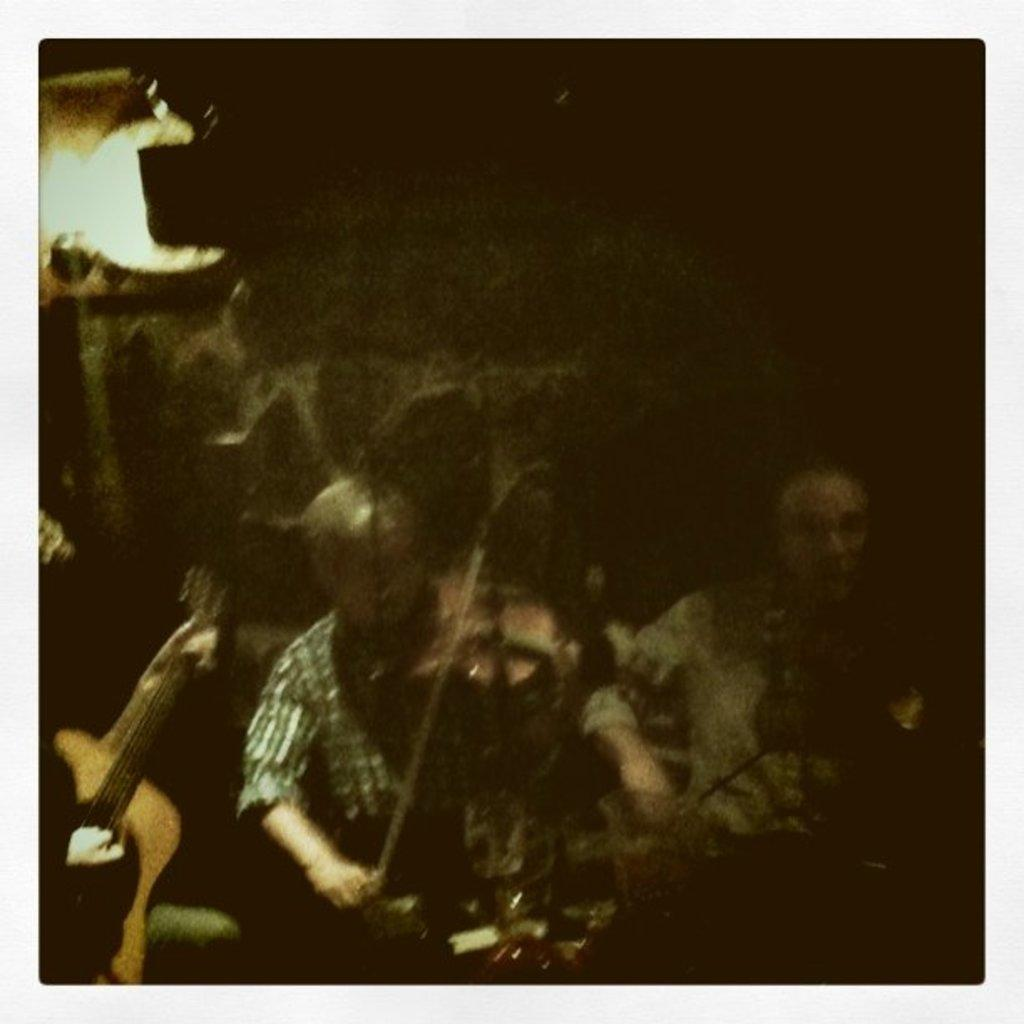How many people are in the image? There are two persons in the image. What are the persons doing in the image? The persons are playing musical instruments. What is the color of the background in the image? The background of the image is dark. Can you describe the lighting in the image? There is a light visible in the image. What type of haircut is the person on the left getting in the image? There is no haircut being performed in the image; the persons are playing musical instruments. What meal is being prepared in the image? There is no meal preparation visible in the image; it features two people playing musical instruments. 